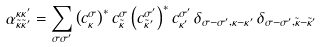Convert formula to latex. <formula><loc_0><loc_0><loc_500><loc_500>\alpha _ { \tilde { \kappa } \tilde { \kappa } ^ { \prime } } ^ { \kappa \kappa ^ { \prime } } = \sum _ { \sigma \sigma ^ { \prime } } \left ( c _ { \kappa } ^ { \sigma } \right ) ^ { * } c _ { \tilde { \kappa } } ^ { \sigma } \left ( c _ { \tilde { \kappa } ^ { \prime } } ^ { \sigma ^ { \prime } } \right ) ^ { * } c _ { \kappa ^ { \prime } } ^ { \sigma ^ { \prime } } \, \delta _ { \sigma - \sigma ^ { \prime } , \kappa - \kappa ^ { \prime } } \, \delta _ { \sigma - \sigma ^ { \prime } , \tilde { \kappa } - \tilde { \kappa } ^ { \prime } }</formula> 